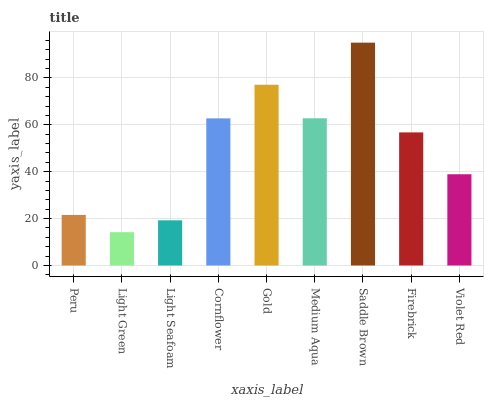Is Light Green the minimum?
Answer yes or no. Yes. Is Saddle Brown the maximum?
Answer yes or no. Yes. Is Light Seafoam the minimum?
Answer yes or no. No. Is Light Seafoam the maximum?
Answer yes or no. No. Is Light Seafoam greater than Light Green?
Answer yes or no. Yes. Is Light Green less than Light Seafoam?
Answer yes or no. Yes. Is Light Green greater than Light Seafoam?
Answer yes or no. No. Is Light Seafoam less than Light Green?
Answer yes or no. No. Is Firebrick the high median?
Answer yes or no. Yes. Is Firebrick the low median?
Answer yes or no. Yes. Is Violet Red the high median?
Answer yes or no. No. Is Peru the low median?
Answer yes or no. No. 